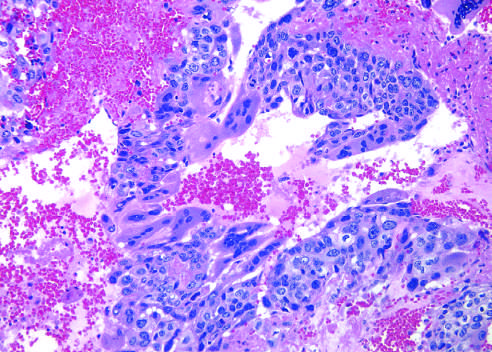re hemorrhage and necrosis prominent?
Answer the question using a single word or phrase. Yes 